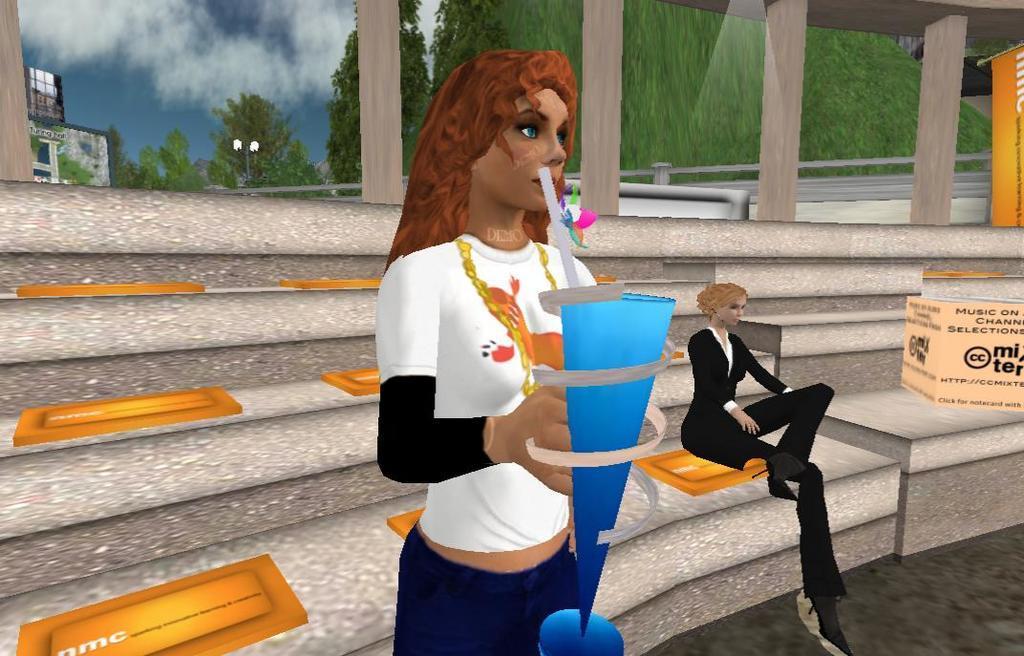Could you give a brief overview of what you see in this image? In this picture I can see an animated image, on which I can see a woman standing and holding an object, side another woman is sitting on the staircases. 